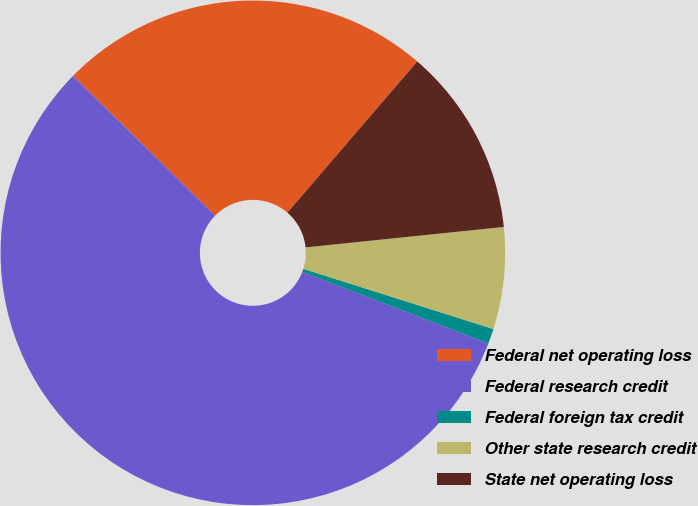<chart> <loc_0><loc_0><loc_500><loc_500><pie_chart><fcel>Federal net operating loss<fcel>Federal research credit<fcel>Federal foreign tax credit<fcel>Other state research credit<fcel>State net operating loss<nl><fcel>23.93%<fcel>56.52%<fcel>0.96%<fcel>6.52%<fcel>12.07%<nl></chart> 